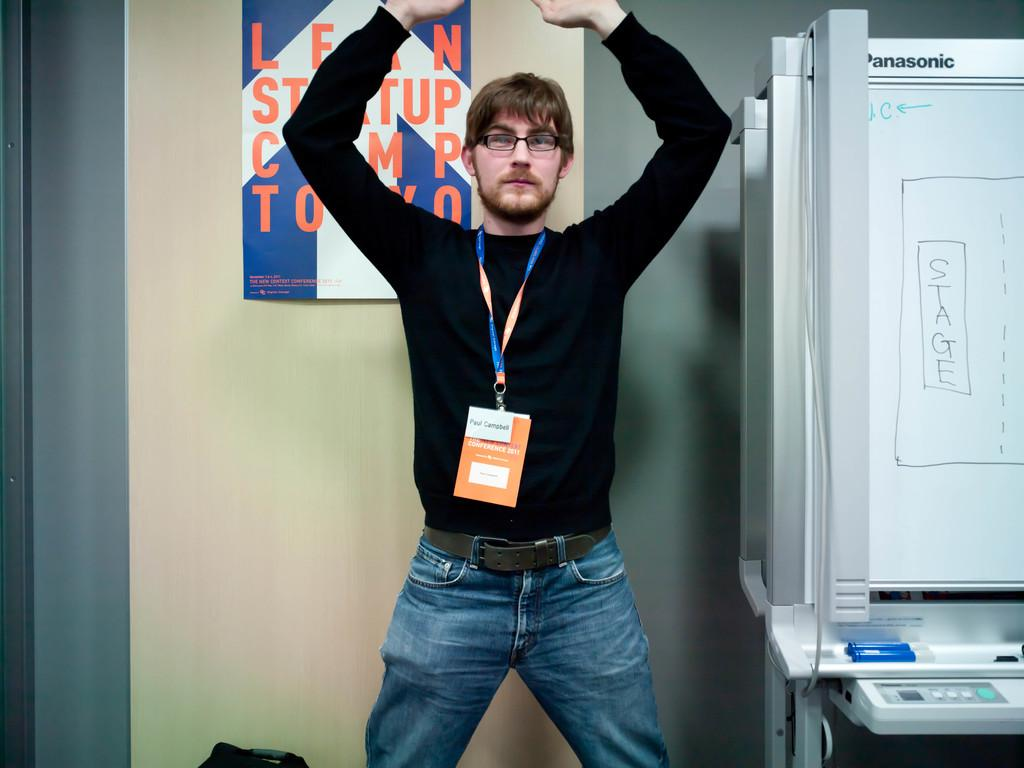<image>
Write a terse but informative summary of the picture. a man holding up his hands next to a Panasonic white board 